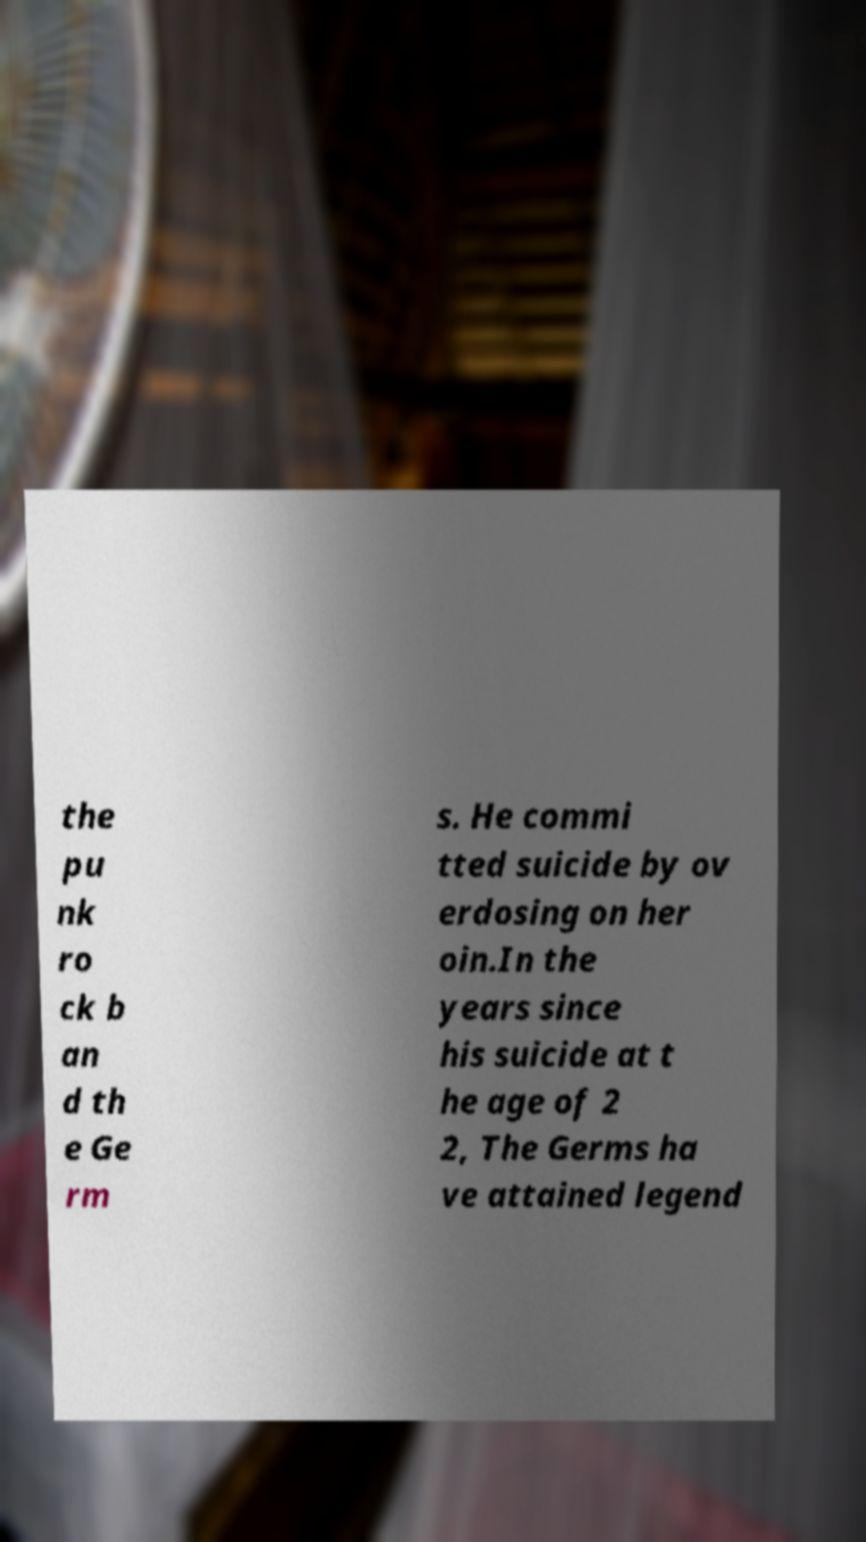What messages or text are displayed in this image? I need them in a readable, typed format. the pu nk ro ck b an d th e Ge rm s. He commi tted suicide by ov erdosing on her oin.In the years since his suicide at t he age of 2 2, The Germs ha ve attained legend 